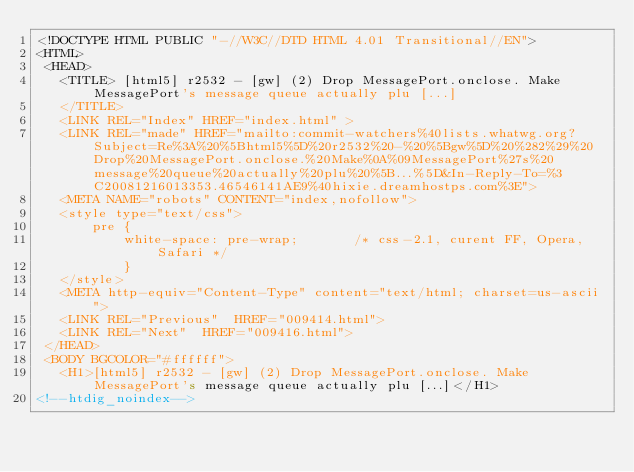<code> <loc_0><loc_0><loc_500><loc_500><_HTML_><!DOCTYPE HTML PUBLIC "-//W3C//DTD HTML 4.01 Transitional//EN">
<HTML>
 <HEAD>
   <TITLE> [html5] r2532 - [gw] (2) Drop MessagePort.onclose. Make	MessagePort's message queue actually plu [...]
   </TITLE>
   <LINK REL="Index" HREF="index.html" >
   <LINK REL="made" HREF="mailto:commit-watchers%40lists.whatwg.org?Subject=Re%3A%20%5Bhtml5%5D%20r2532%20-%20%5Bgw%5D%20%282%29%20Drop%20MessagePort.onclose.%20Make%0A%09MessagePort%27s%20message%20queue%20actually%20plu%20%5B...%5D&In-Reply-To=%3C20081216013353.46546141AE9%40hixie.dreamhostps.com%3E">
   <META NAME="robots" CONTENT="index,nofollow">
   <style type="text/css">
       pre {
           white-space: pre-wrap;       /* css-2.1, curent FF, Opera, Safari */
           }
   </style>
   <META http-equiv="Content-Type" content="text/html; charset=us-ascii">
   <LINK REL="Previous"  HREF="009414.html">
   <LINK REL="Next"  HREF="009416.html">
 </HEAD>
 <BODY BGCOLOR="#ffffff">
   <H1>[html5] r2532 - [gw] (2) Drop MessagePort.onclose. Make	MessagePort's message queue actually plu [...]</H1>
<!--htdig_noindex--></code> 